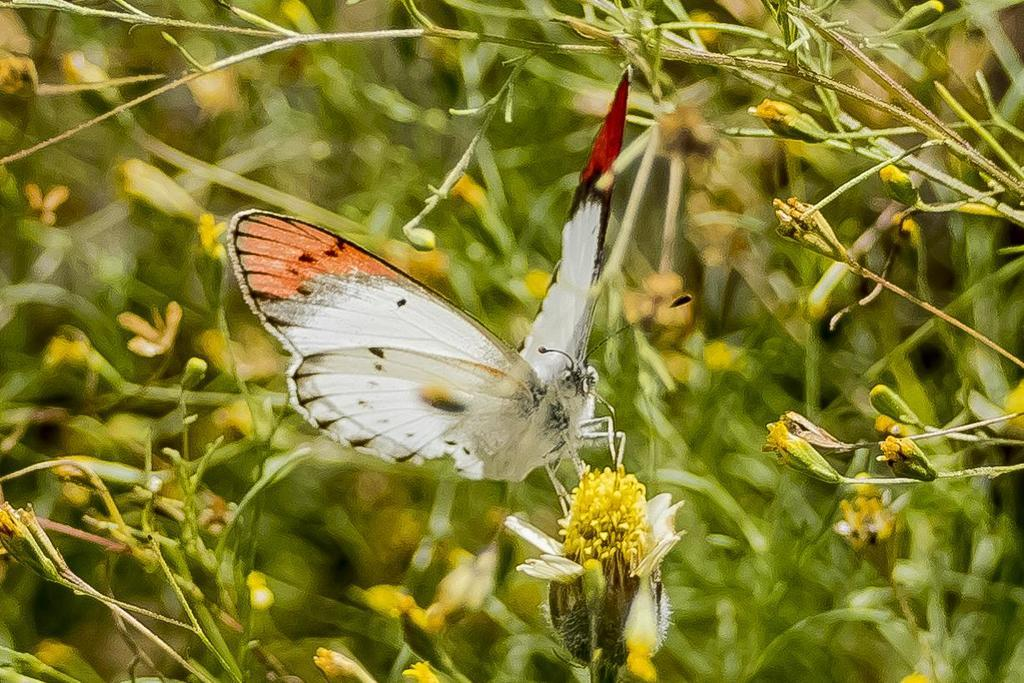What is the main subject of the image? The main subject of the image is a butterfly on a flower. Can you describe the flower that the butterfly is on? Unfortunately, the facts provided do not give a detailed description of the flower. What can be seen in the background of the image? There are plants visible in the background of the image. What type of sound can be heard coming from the butterfly in the image? Butterflies do not make sounds that can be heard by humans, so there is no sound coming from the butterfly in the image. 